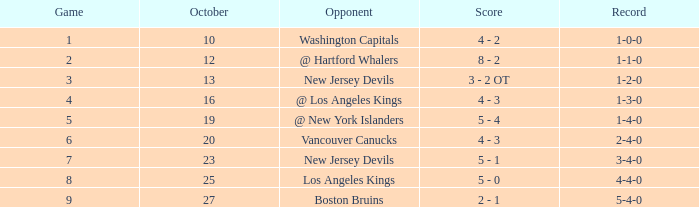Which game recorded the maximum score of 9 in october? 27.0. 